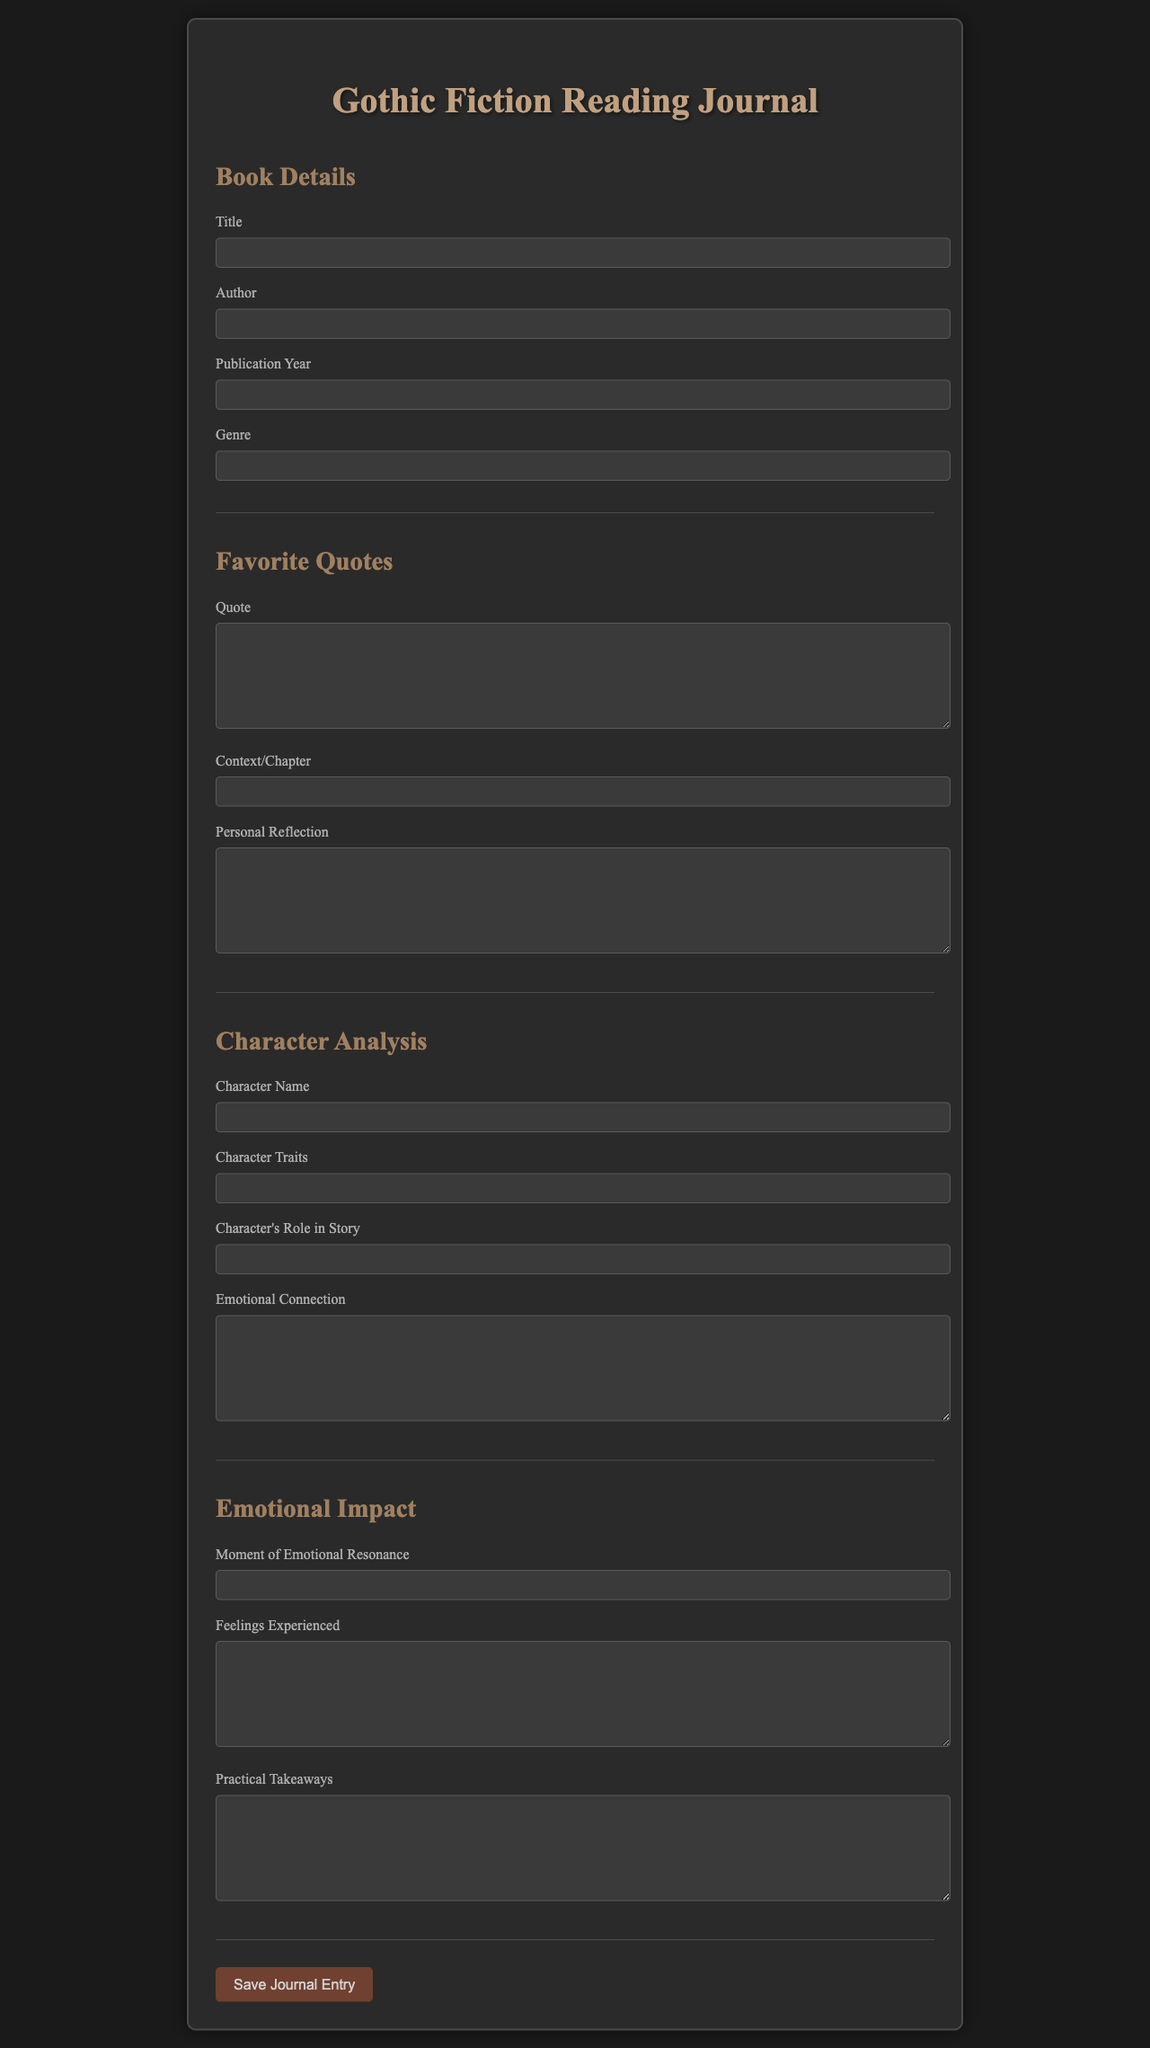what is the title of the form? The title of the form is displayed prominently at the top of the document.
Answer: Gothic Fiction Reading Journal who is the author section intended for? The author section is meant for capturing the name of the author of the gothic fiction book being analyzed.
Answer: Author what kind of quotes can be added in the favorite quotes section? The document allows input for notable quotes from the book, which can resonate with the reader.
Answer: Quote what is required under the emotional impact section? This section requires the user to provide feelings experienced, which reflects the emotional engagement with the text.
Answer: Feelings Experienced what role does the character play according to the character analysis section? The character's role refers to how the character contributes to the overall narrative of the gothic fiction book.
Answer: Character's Role in Story how many main sections are there in the document? The document contains six distinct sections that are organized around different aspects of reading a gothic novel.
Answer: Four what is the purpose of the reflection field in the favorite quotes section? This field is meant for the reader to introspect on their personal connection to the quoted material.
Answer: Personal Reflection what does the submission button say? The button is for saving the entries completed in the form.
Answer: Save Journal Entry what emotional aspect does the emotional resonance field focus on? This field captures specific moments within the text that invoke strong feelings from the reader.
Answer: Moment of Emotional Resonance 